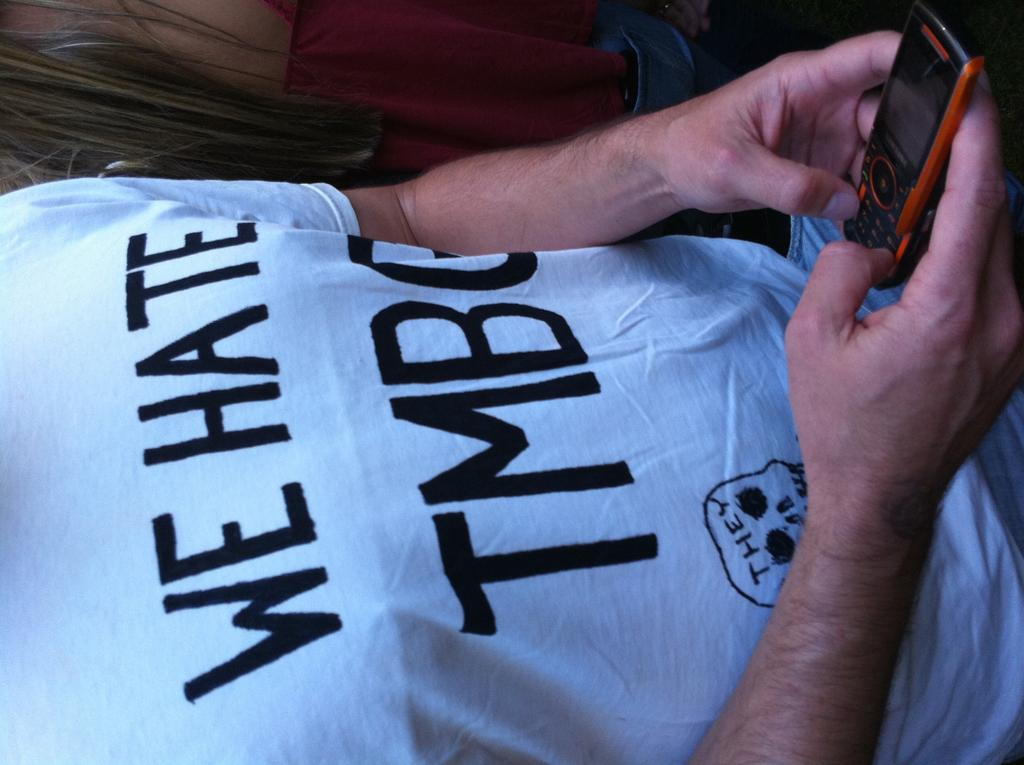<image>
Provide a brief description of the given image. A shirt that has We Hate TMBG on it. 